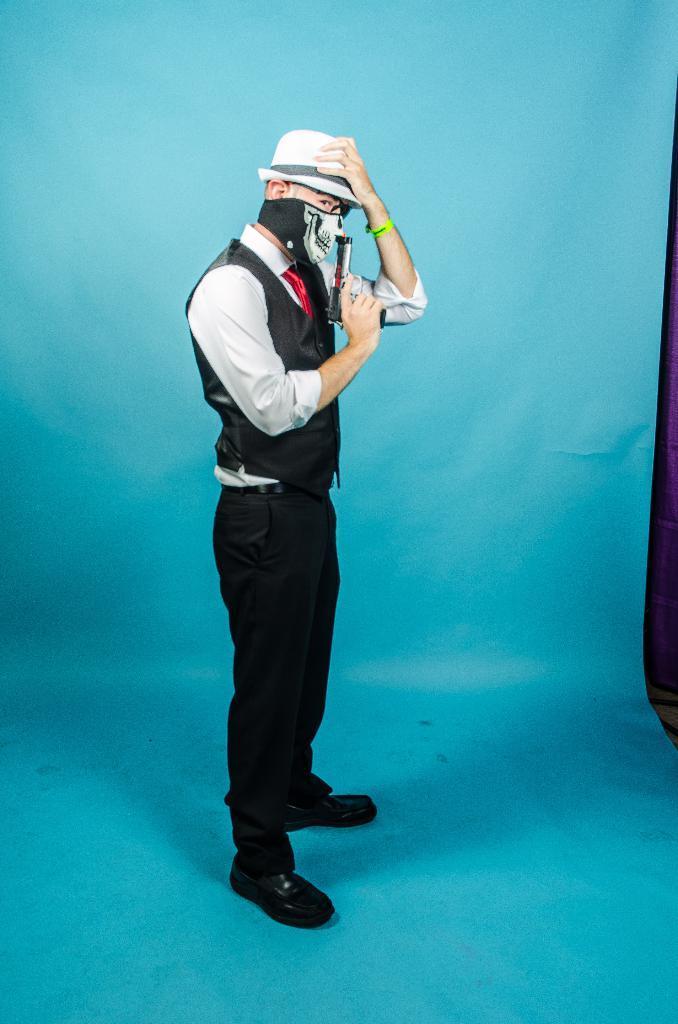Could you give a brief overview of what you see in this image? In this picture there is a person standing and holding a gun and wore a mask and hat. In the background of the image it is blue. 